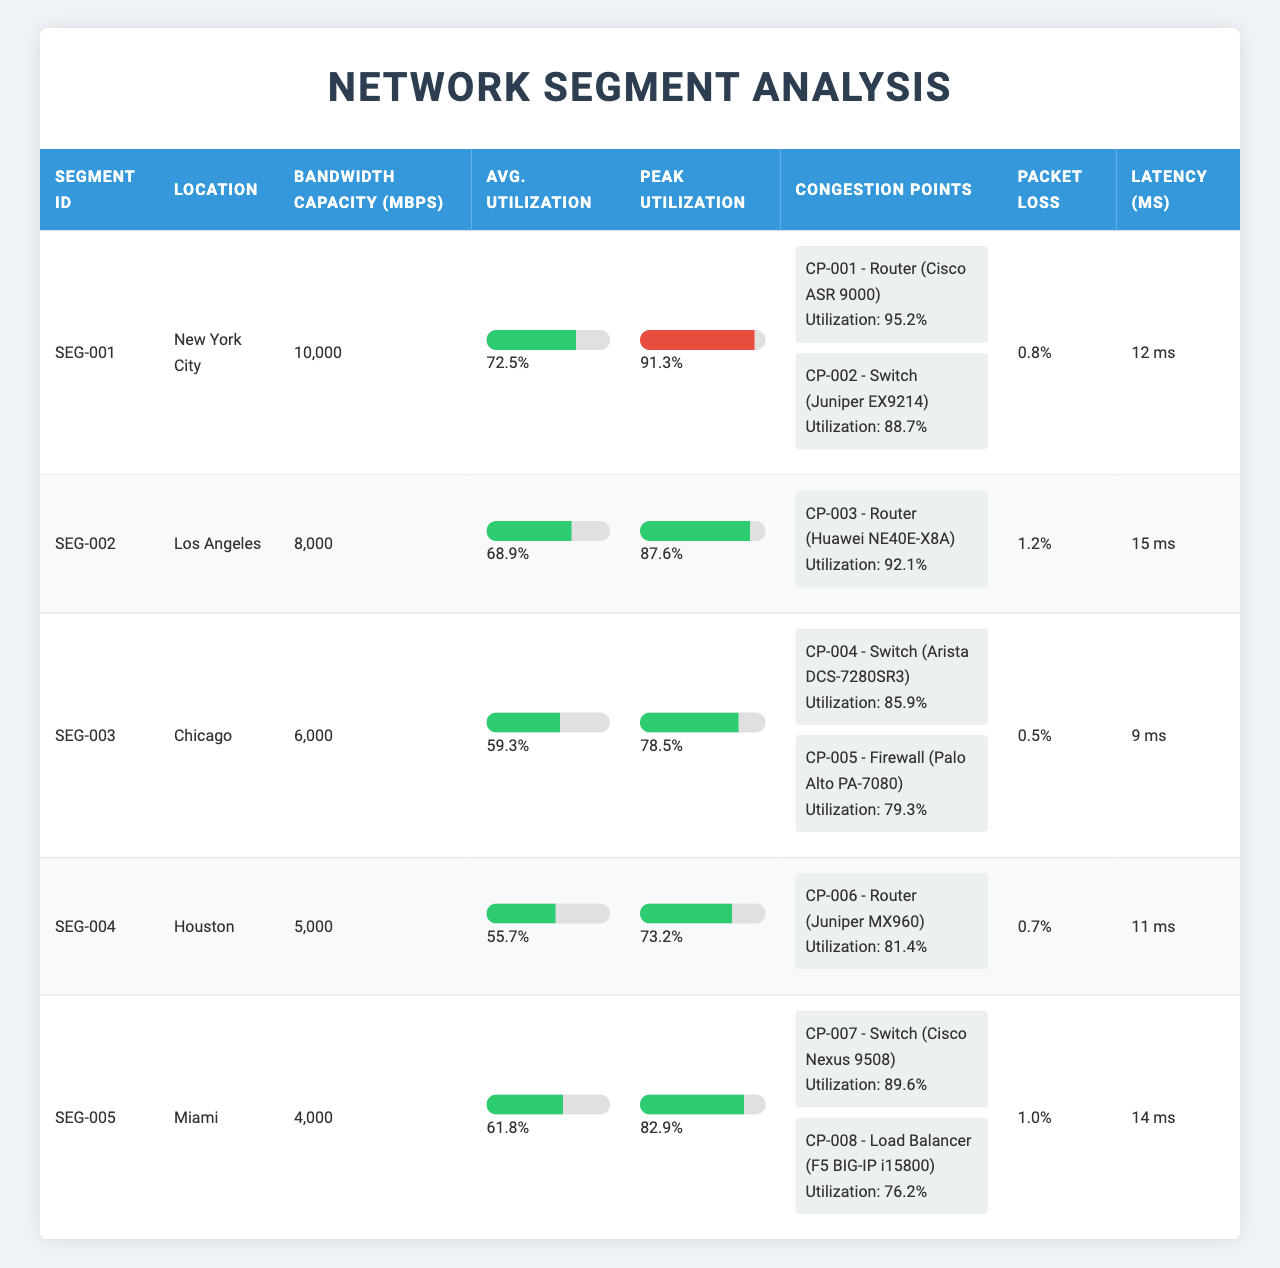What is the location of segment SEG-002? The table states that SEG-002 is located in Los Angeles.
Answer: Los Angeles What is the packet loss percentage for the Chicago network segment? In the Chicago segment (SEG-003), the packet loss percentage is listed as 0.5%.
Answer: 0.5% Which segment has the highest peak utilization percentage? The peak utilization percentage for New York City (SEG-001) is 91.3%, which is higher than the other segments.
Answer: SEG-001 (91.3%) How many congestion points are there in the Miami network segment? Miami (SEG-005) has two congestion points: CP-007 and CP-008.
Answer: 2 What is the average utilization of the Houston network segment? The average utilization percentage for Houston (SEG-004) is provided as 55.7%.
Answer: 55.7% Which device in the New York City segment has the highest utilization percentage? The router (CP-001) with model Cisco ASR 9000 has the highest utilization percentage at 95.2%.
Answer: Cisco ASR 9000 What is the average bandwidth capacity across all segments? The bandwidth capacities are 10000, 8000, 6000, 5000, and 4000. The sum is 40000 and there are 5 segments, resulting in an average of 40000/5 = 8000.
Answer: 8000 Mbps Is there any segment with a latency greater than 15 ms? Yes, the latency for New York City (SEG-001) is 12 ms, and for Los Angeles (SEG-002) it's 15 ms, which are both not greater than 15 ms, but Miami (SEG-005) has a latency of 14 ms, so no segment has a latency greater than 15 ms.
Answer: No Which segment has the lowest average utilization percentage? The lowest average utilization percentage is for Houston (SEG-004) at 55.7%.
Answer: SEG-004 (55.7%) How do the average utilization percentages of the New York City and Chicago segments compare? New York City has an average utilization of 72.5%, while Chicago has 59.3%. The difference is 72.5 - 59.3 = 13.2, indicating New York City has higher average utilization.
Answer: New York City has higher average utilization What device type in Los Angeles has the highest utilization percentage? The router (CP-003) of model Huawei NE40E-X8A has the highest utilization percentage at 92.1%.
Answer: Router Which location has the lowest bandwidth capacity? Miami has the lowest bandwidth capacity at 4000 Mbps.
Answer: Miami (4000 Mbps) 